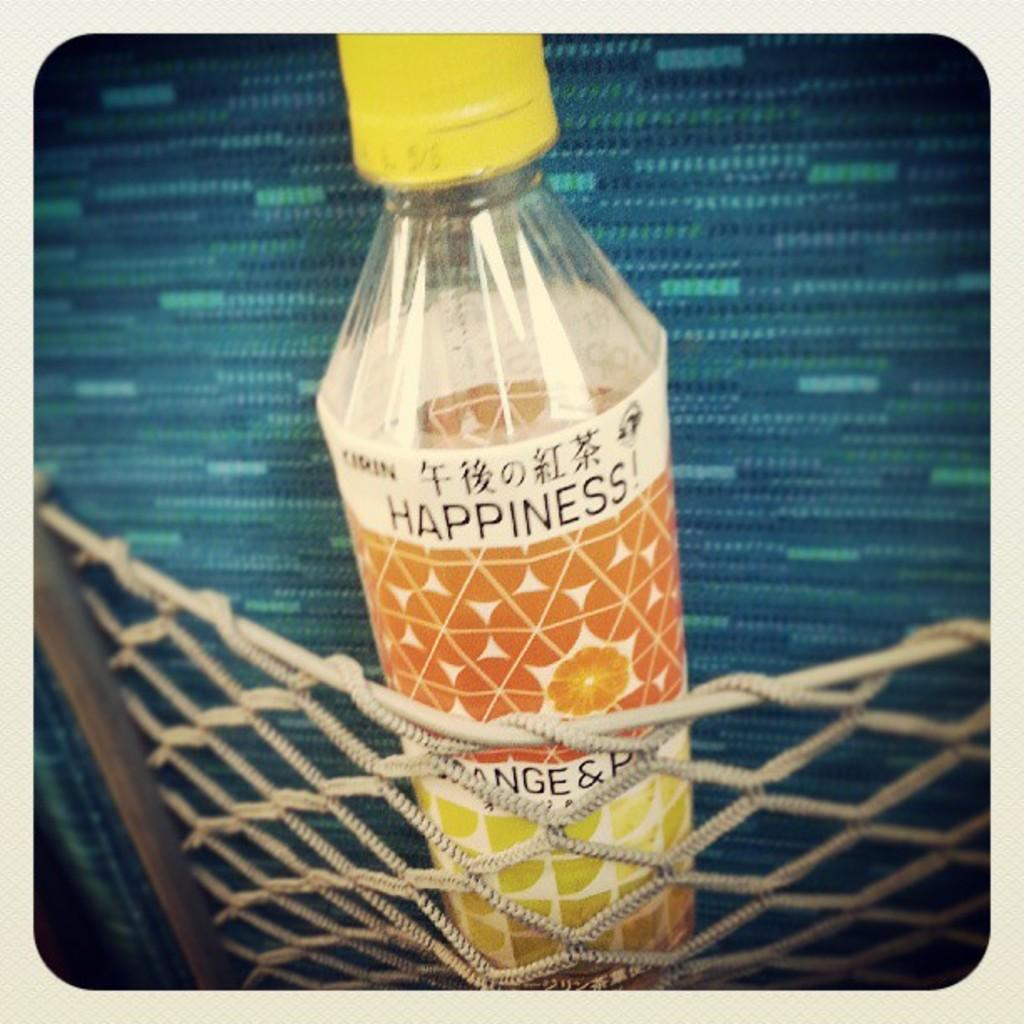<image>
Give a short and clear explanation of the subsequent image. A bottle with a yellow top has the word happiness written on it. 